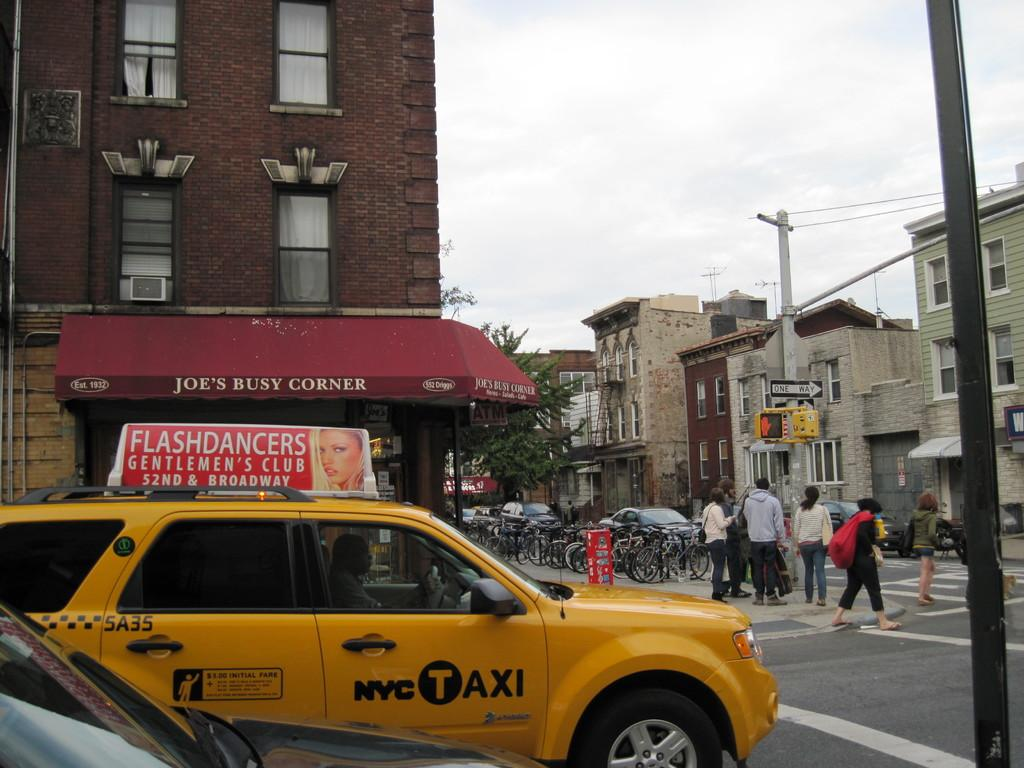<image>
Write a terse but informative summary of the picture. A yellow taxi cab stopped in front of Joe's Busy Corner shop. 